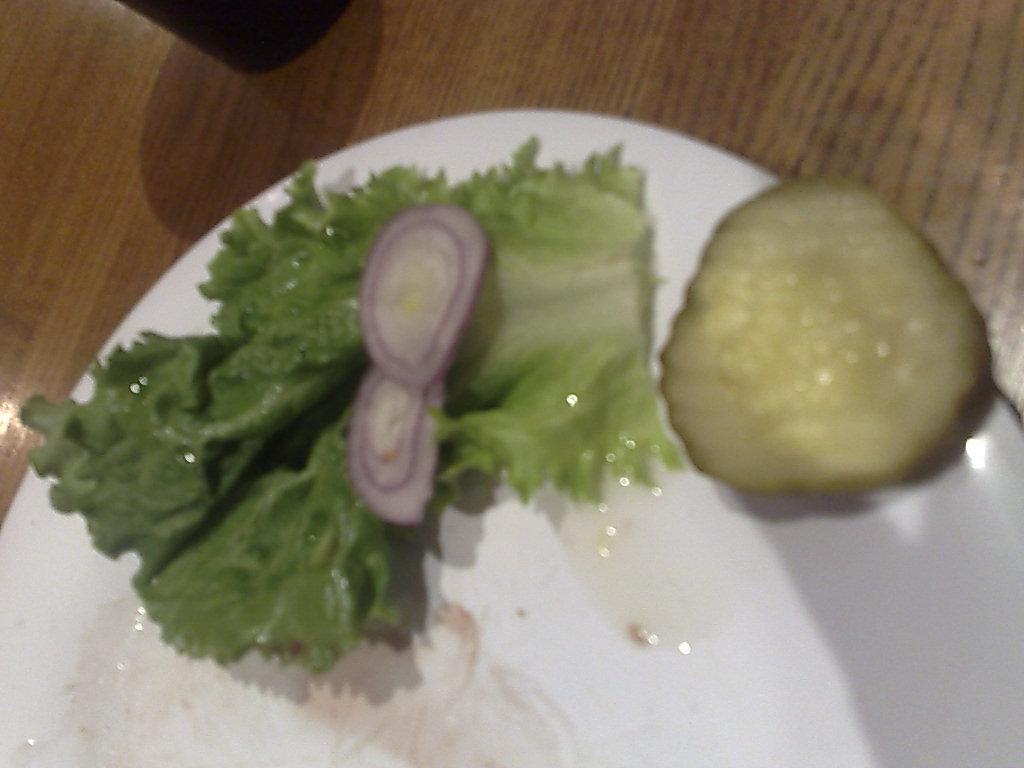Can you describe this image briefly? In this picture there is a table, on the table there is a plate. On the plate there are onions slices and leafy vegetable. At the top there is a cup. 